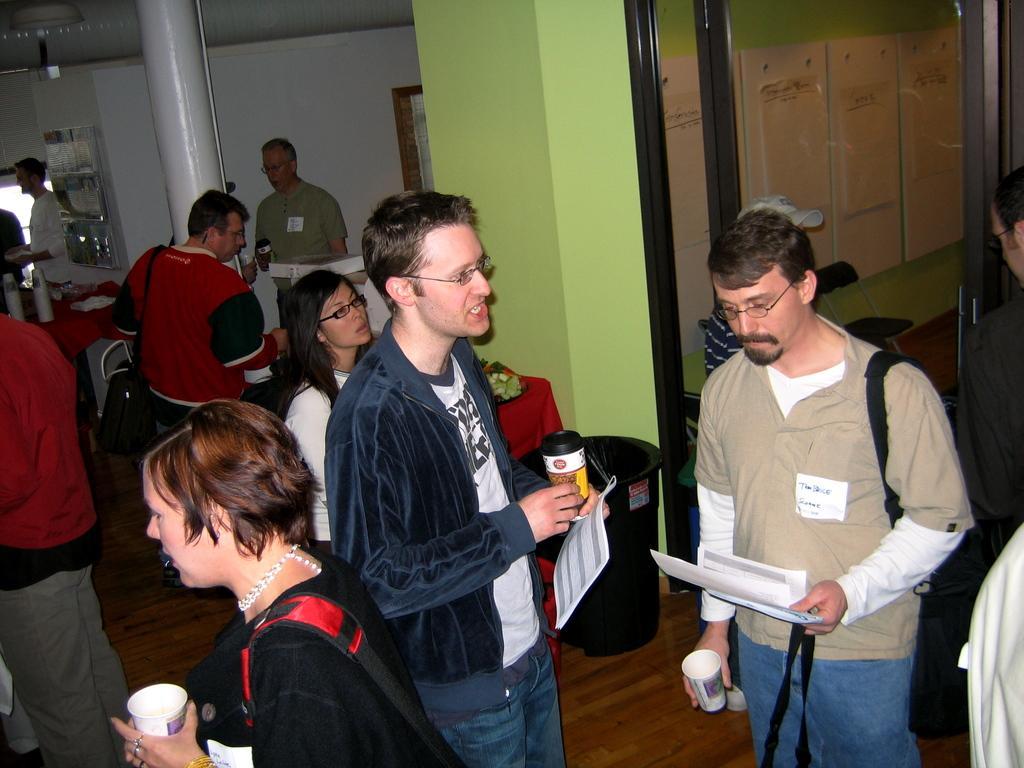Describe this image in one or two sentences. Here in this picture we can see number of people standing and walking on the floor over there and we can see all of them are carrying papers and coffee cups in their hands and some of them are carrying bags on them also and in the middle we can see a pillar present over there and on the right side we can see a door present over there. 